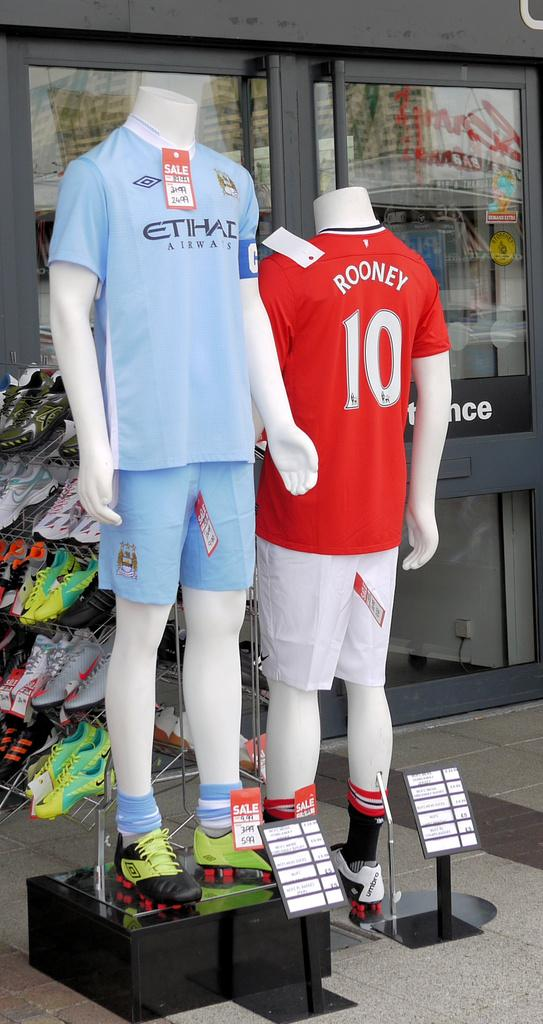<image>
Describe the image concisely. Two mannequins are outside of a store and one is wearing a shirt with rooney written on it. 